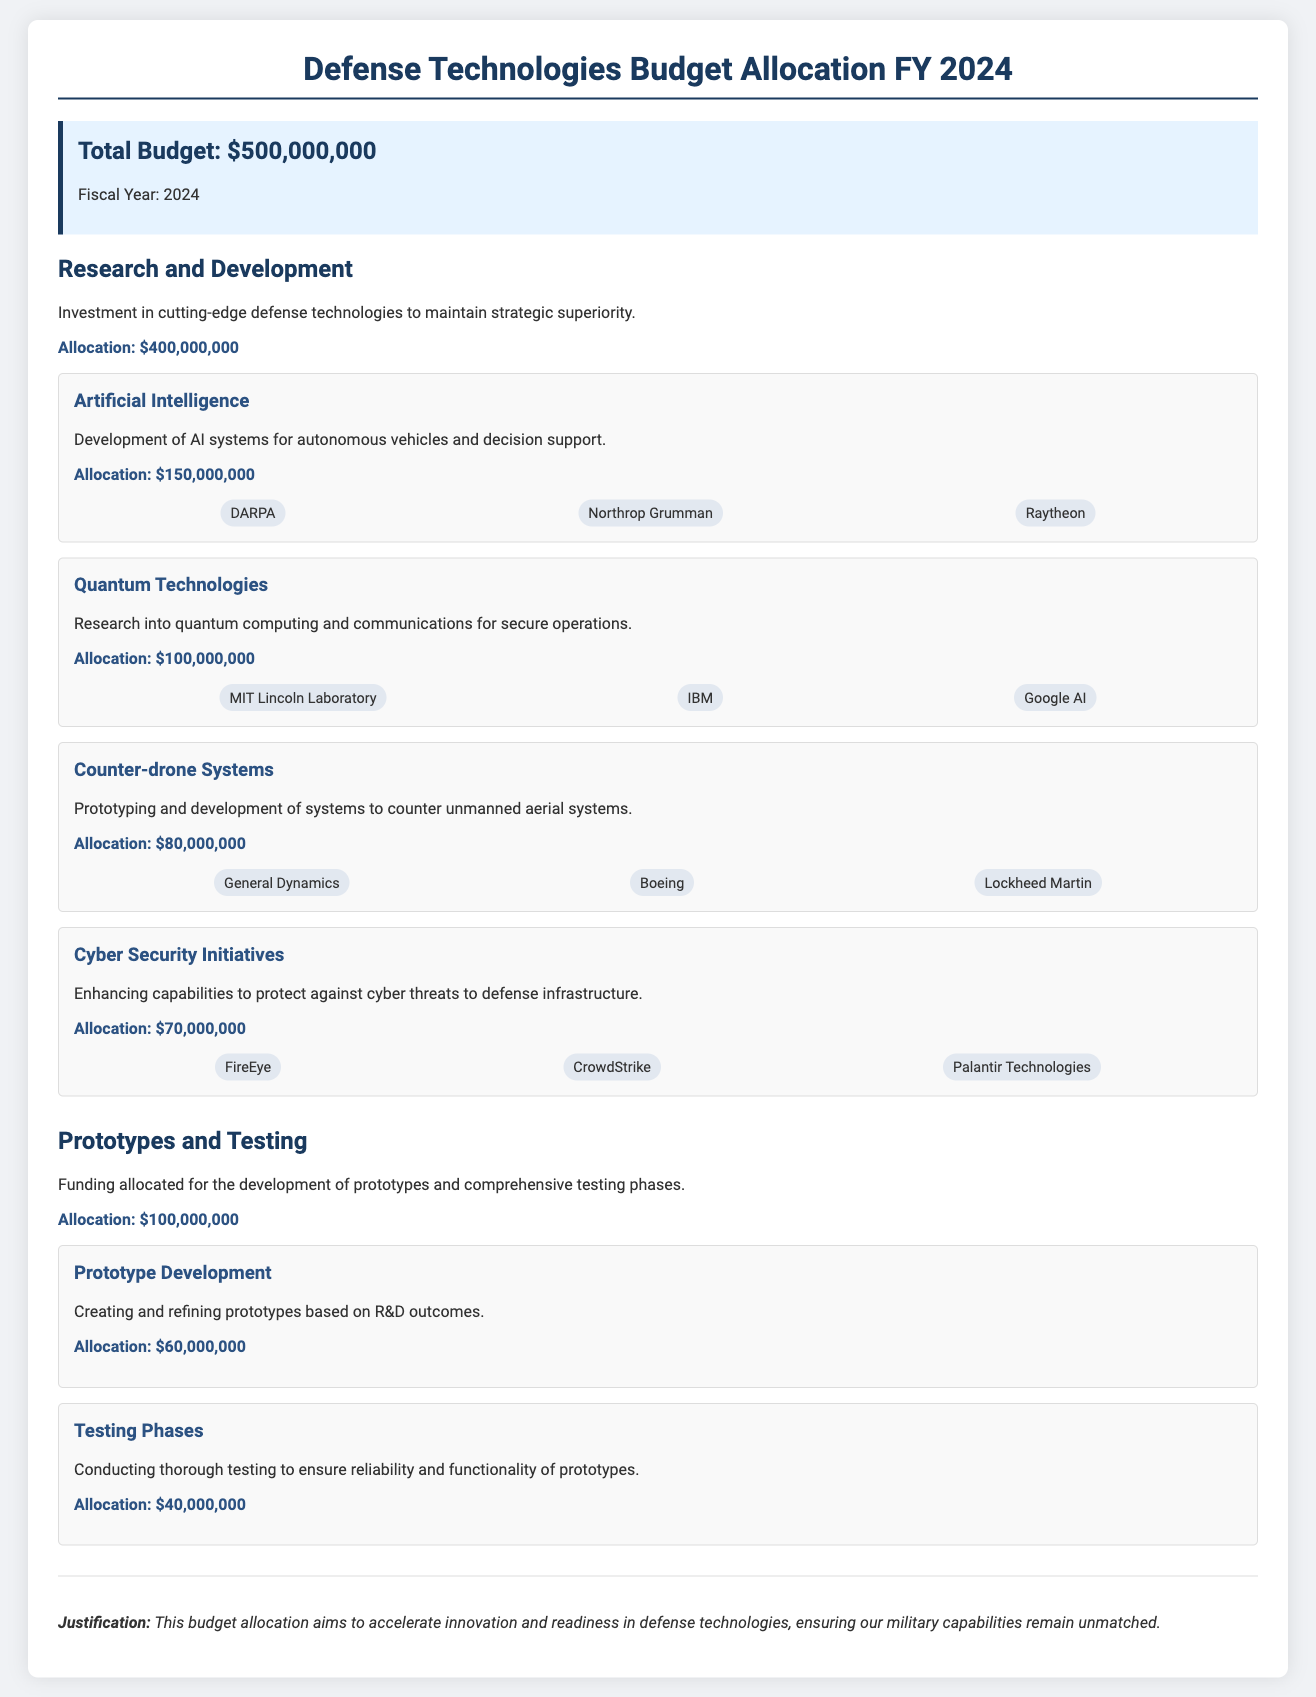what is the total budget? The total budget is stated at the top of the document as $500,000,000.
Answer: $500,000,000 how much is allocated for Research and Development? The document specifies that $400,000,000 is allocated for Research and Development.
Answer: $400,000,000 which organization is involved in Artificial Intelligence development? The document mentions DARPA, Northrop Grumman, and Raytheon as key entities in Artificial Intelligence.
Answer: DARPA, Northrop Grumman, Raytheon what is the allocation for Cyber Security Initiatives? The budget shows that $70,000,000 is allocated specifically for Cyber Security Initiatives.
Answer: $70,000,000 how much funding is set for Testing Phases? It is indicated in the document that $40,000,000 is allocated for Testing Phases.
Answer: $40,000,000 which category has the highest allocation? Research and Development has the highest allocation as presented in the document.
Answer: Research and Development what is the purpose of the Prototypes and Testing category? The document states that this category is for the development of prototypes and comprehensive testing phases.
Answer: Development of prototypes and comprehensive testing phases how much is allocated for Prototype Development? The document specifies that $60,000,000 is set aside for Prototype Development.
Answer: $60,000,000 what is the justification for this budget allocation? The justification provided in the document aims to accelerate innovation and ensure unmatched military capabilities.
Answer: Accelerate innovation and ensure unmatched military capabilities 